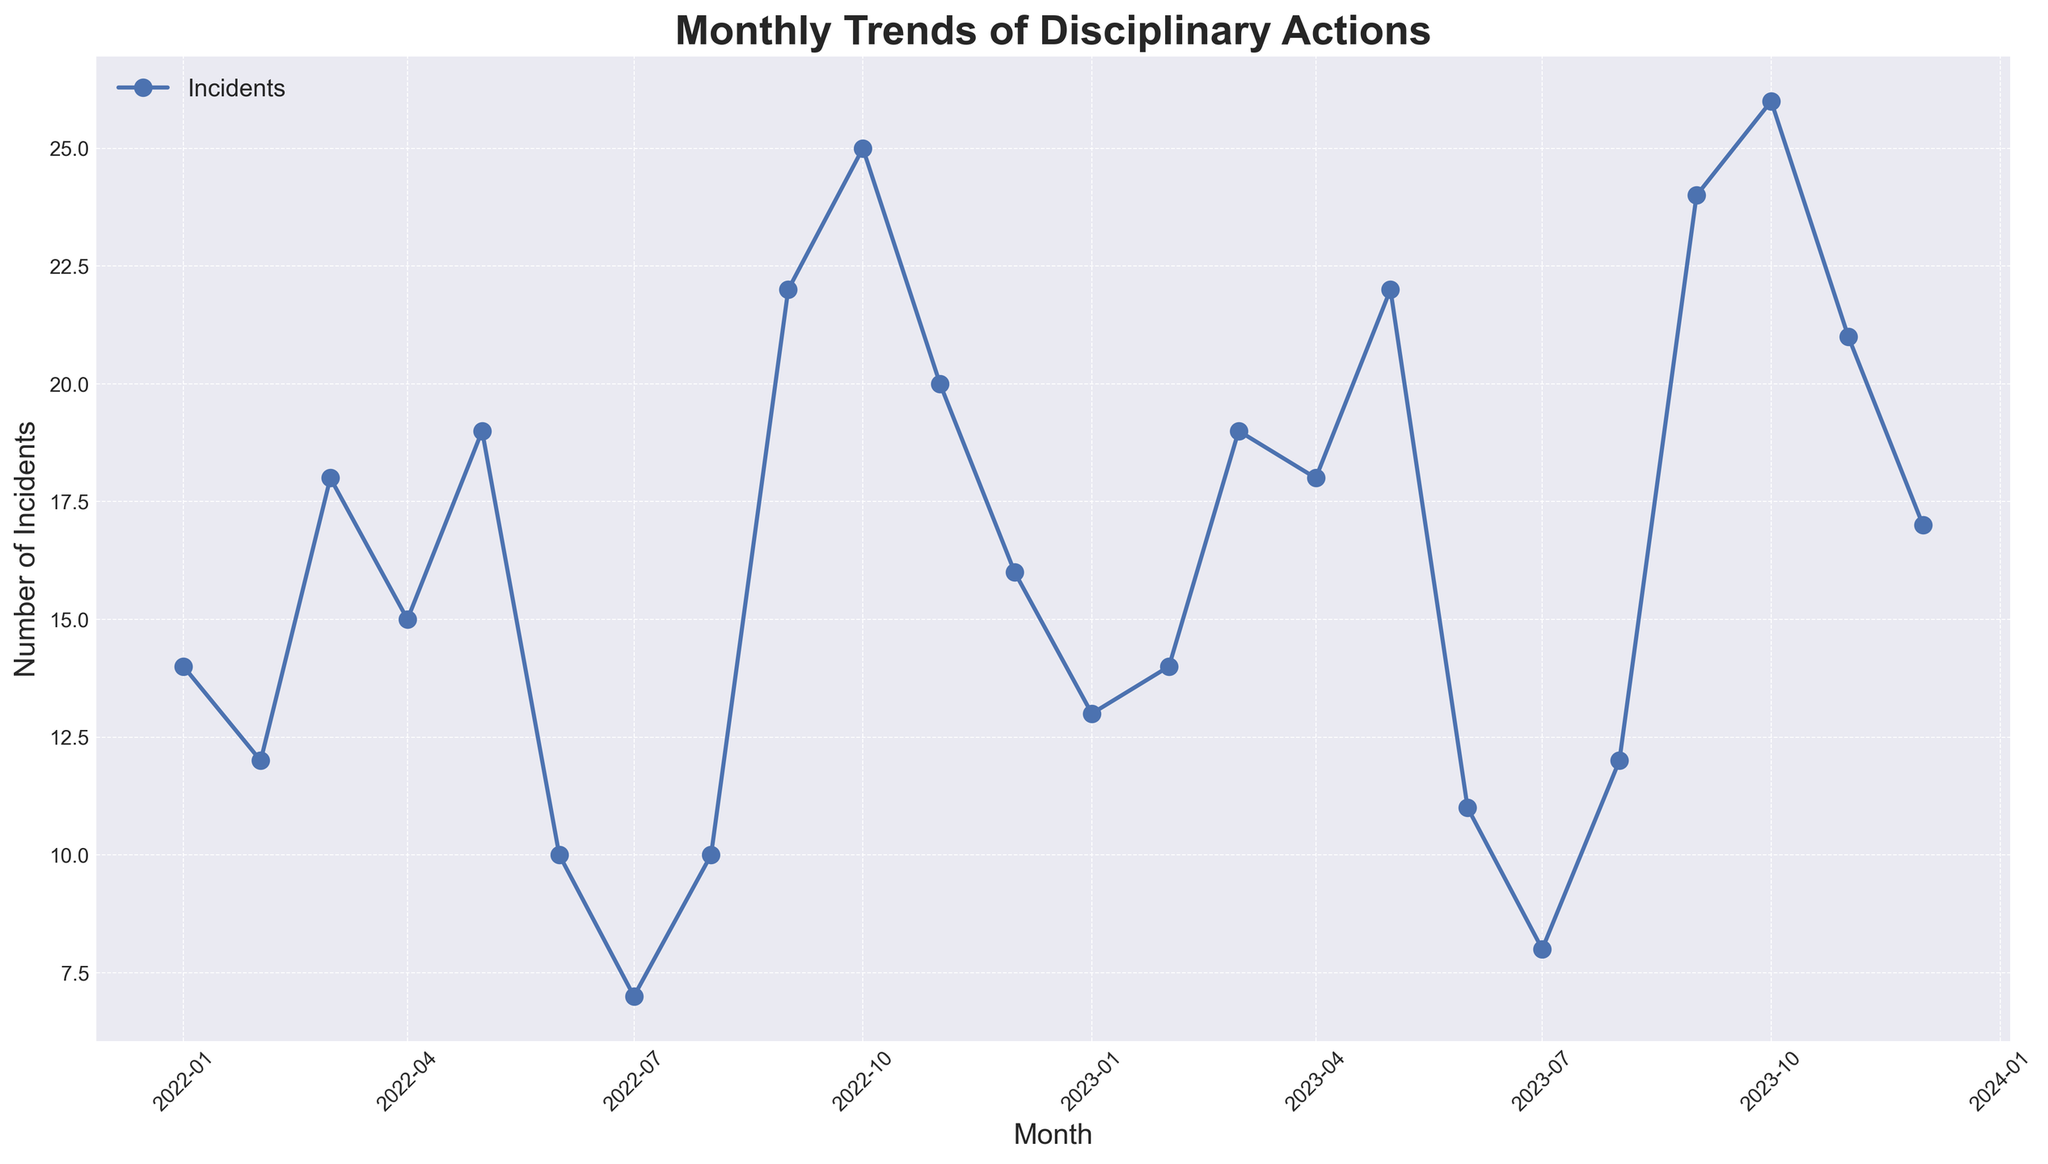What's the highest number of incidents recorded in a single month? Look for the peak in the line chart. The highest point corresponds to October 2023, with 26 incidents.
Answer: 26 How many months had more than 20 incidents? Visually inspect the chart for months where the incident count surpasses 20. These months are Sep-2022, Oct-2022, May-2023, Sep-2023, Oct-2023, and Nov-2023, totaling 6 months.
Answer: 6 What is the difference in the number of incidents between June 2022 and June 2023? Locate the points for June 2022 and June 2023 and subtract the incidents. June 2022 has 10 incidents, and June 2023 has 11 incidents. The difference is 1.
Answer: 1 Which month had fewer incidents: July 2022 or July 2023? Compare the points for July 2022 and July 2023. July 2022 has 7 incidents, and July 2023 has 8 incidents. July 2022 had fewer incidents.
Answer: July 2022 How many incidents were reported in the months of March across both years? Add the incidents for March 2022 (18) and March 2023 (19). The total is 37.
Answer: 37 What is the average number of incidents per month in 2022? Sum incident counts from Jan 2022 to Dec 2022 and divide by 12. The sum is 188, so the average is 188 / 12 = 15.67.
Answer: 15.67 Which quarter in 2023 had the lowest average incidents? Calculate the quarterly averages: 
Q1 (Jan-Mar): (13 + 14 + 19) / 3 = 15.33,
Q2 (Apr-Jun): (18 + 22 + 11) / 3 = 17,
Q3 (Jul-Sep): (8 + 12 + 24) / 3 = 14.67,
Q4 (Oct-Dec): (26 + 21 + 17) / 3 = 21.33. 
Q3 has the lowest average incidents.
Answer: Q3 Are there any months where the number of incidents is the same in both years? Compare same months across 2022 and 2023. Only February has the same incident count (12 in 2022, 14 in 2023).
Answer: February 